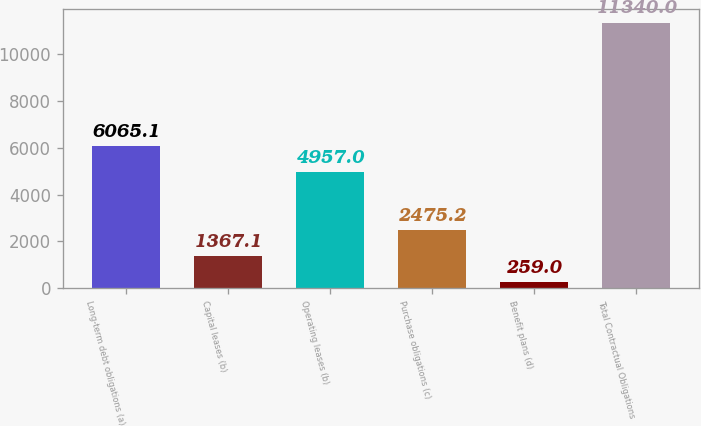Convert chart to OTSL. <chart><loc_0><loc_0><loc_500><loc_500><bar_chart><fcel>Long-term debt obligations (a)<fcel>Capital leases (b)<fcel>Operating leases (b)<fcel>Purchase obligations (c)<fcel>Benefit plans (d)<fcel>Total Contractual Obligations<nl><fcel>6065.1<fcel>1367.1<fcel>4957<fcel>2475.2<fcel>259<fcel>11340<nl></chart> 